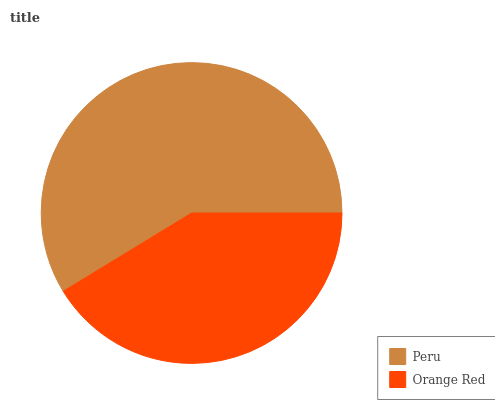Is Orange Red the minimum?
Answer yes or no. Yes. Is Peru the maximum?
Answer yes or no. Yes. Is Orange Red the maximum?
Answer yes or no. No. Is Peru greater than Orange Red?
Answer yes or no. Yes. Is Orange Red less than Peru?
Answer yes or no. Yes. Is Orange Red greater than Peru?
Answer yes or no. No. Is Peru less than Orange Red?
Answer yes or no. No. Is Peru the high median?
Answer yes or no. Yes. Is Orange Red the low median?
Answer yes or no. Yes. Is Orange Red the high median?
Answer yes or no. No. Is Peru the low median?
Answer yes or no. No. 